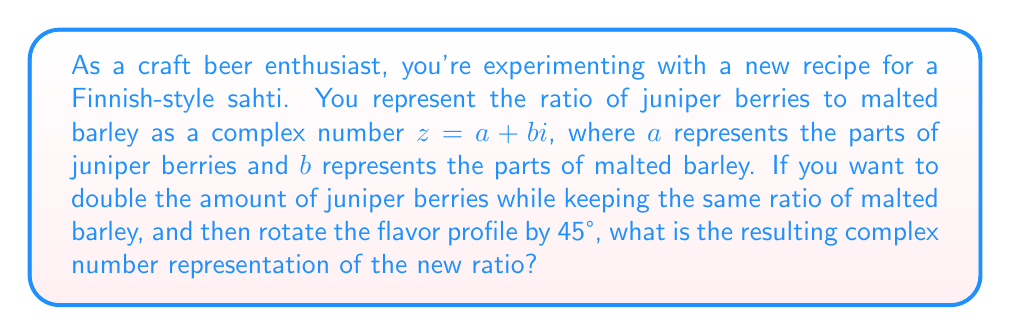Give your solution to this math problem. Let's approach this step-by-step:

1) The initial ratio is represented by $z = a + bi$.

2) To double the amount of juniper berries while keeping the same ratio of malted barley, we multiply the real part by 2:

   $z_1 = 2a + bi$

3) To rotate the flavor profile by 45°, we need to multiply by $e^{i\theta}$, where $\theta = 45° = \frac{\pi}{4}$ radians:

   $z_2 = z_1 \cdot e^{i\frac{\pi}{4}}$

4) We know that $e^{i\frac{\pi}{4}} = \cos(\frac{\pi}{4}) + i\sin(\frac{\pi}{4}) = \frac{\sqrt{2}}{2} + i\frac{\sqrt{2}}{2}$

5) Now, let's multiply:

   $z_2 = (2a + bi)(\frac{\sqrt{2}}{2} + i\frac{\sqrt{2}}{2})$

6) Expanding this:

   $z_2 = (2a\frac{\sqrt{2}}{2} - b\frac{\sqrt{2}}{2}) + i(2a\frac{\sqrt{2}}{2} + b\frac{\sqrt{2}}{2})$

7) Simplifying:

   $z_2 = (a\sqrt{2} - \frac{b\sqrt{2}}{2}) + i(a\sqrt{2} + \frac{b\sqrt{2}}{2})$

This is the final complex number representation of the new ratio.
Answer: $(a\sqrt{2} - \frac{b\sqrt{2}}{2}) + i(a\sqrt{2} + \frac{b\sqrt{2}}{2})$ 